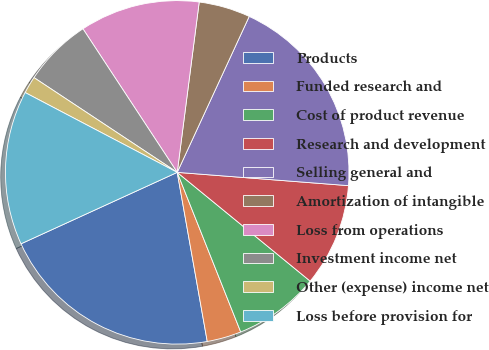<chart> <loc_0><loc_0><loc_500><loc_500><pie_chart><fcel>Products<fcel>Funded research and<fcel>Cost of product revenue<fcel>Research and development<fcel>Selling general and<fcel>Amortization of intangible<fcel>Loss from operations<fcel>Investment income net<fcel>Other (expense) income net<fcel>Loss before provision for<nl><fcel>20.97%<fcel>3.23%<fcel>8.06%<fcel>9.68%<fcel>19.35%<fcel>4.84%<fcel>11.29%<fcel>6.45%<fcel>1.61%<fcel>14.52%<nl></chart> 